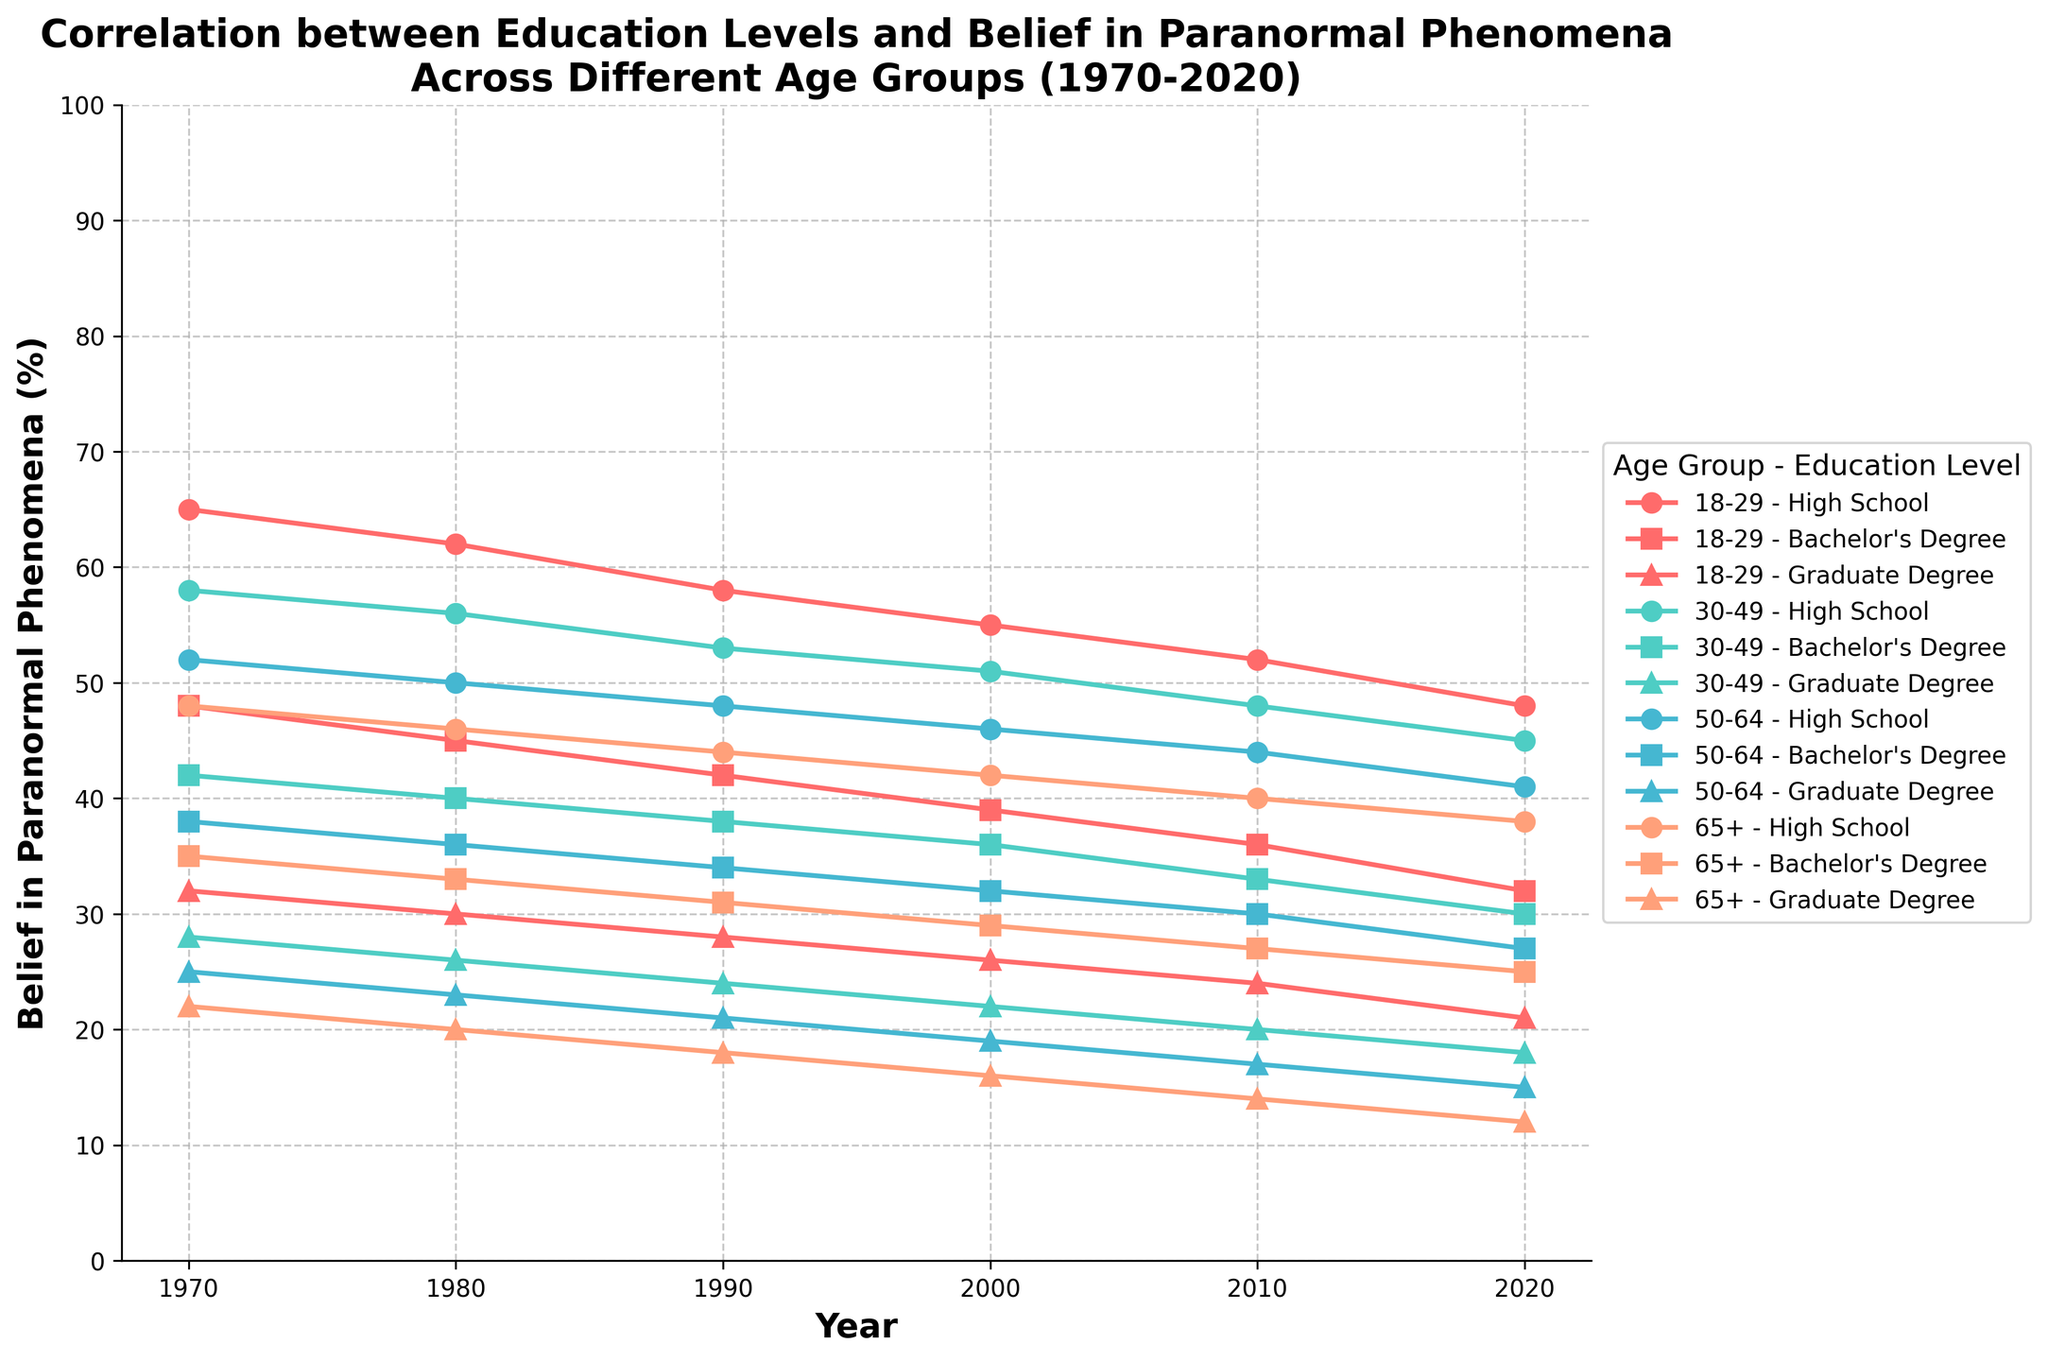What trend in belief in paranormal phenomena can be seen in the 18-29 age group with a high school education from 1970 to 2020? Observing the plot for the 18-29 age group with a high school education, their belief in paranormal phenomena decreases consistently from 65% in 1970 to 48% in 2020. This trend shows a steady decline over time.
Answer: A steady decline Which age group with a bachelor's degree had the least belief in paranormal phenomena in 2020? To identify the age group with the least belief in paranormal phenomena who have a bachelor's degree, we compare the data for all age groups with bachelor's degrees in 2020. The 65+ age group shows the lowest percentage at 25%.
Answer: 65+ In 1990, how does belief in paranormal phenomena for the 30-49 age group with a graduate degree compare to the 18-29 age group with a high school education? In 1990, the belief in paranormal phenomena for the 30-49 age group with a graduate degree is 24%, whereas for the 18-29 age group with a high school education, it is 58%. The 18-29 age group with a high school education has a higher belief than the 30-49 age group with a graduate degree.
Answer: 18-29 higher What is the average belief in paranormal phenomena across all age groups with a graduate degree in 1980? The belief percentages for graduate degree holders in 1980 are 30% (18-29), 26% (30-49), 23% (50-64), and 20% (65+). Averaging these values, (30 + 26 + 23 + 20) / 4 = 24.75%.
Answer: 24.75% Between which years did the 50-64 age group with a high school education see the greatest decline in belief in paranormal phenomena? By examining the trend lines for the 50-64 age group with high school education, the greatest decline occurred between 2010 (44%) and 2020 (41%). This 3% drop is the largest single-period decrease when compared to other decade intervals for this group.
Answer: 2010-2020 How does the belief in paranormal phenomena in 2000 for the 65+ age group with a high school education compare to the 30-49 age group with a bachelor's degree? In 2000, the belief in paranormal phenomena for the 65+ age group with a high school education is 42%, whereas for the 30-49 age group with a bachelor's degree it is 36%. The 65+ age group with a high school education has a higher belief.
Answer: 65+ higher For the 18-29 age group with a bachelor's degree, identify the total decrease in belief in paranormal phenomena from 1970 to 2020. To find the total decrease, we subtract the 2020 value (32%) from the 1970 value (48%), which results in a decrease of 16 percentage points.
Answer: 16% By how much did the belief in paranormal phenomena change for the 30-49 age group with a bachelor's degree from 1980 to 2000? In 1980, the belief for the 30-49 age group with a bachelor's degree was 40%, and in 2000, it was 36%. The change is 40% - 36% = 4%, indicating a decline.
Answer: 4% decline 